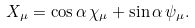Convert formula to latex. <formula><loc_0><loc_0><loc_500><loc_500>X _ { \mu } = \cos \alpha \, \chi _ { \mu } + \sin \alpha \, \psi _ { \mu } .</formula> 